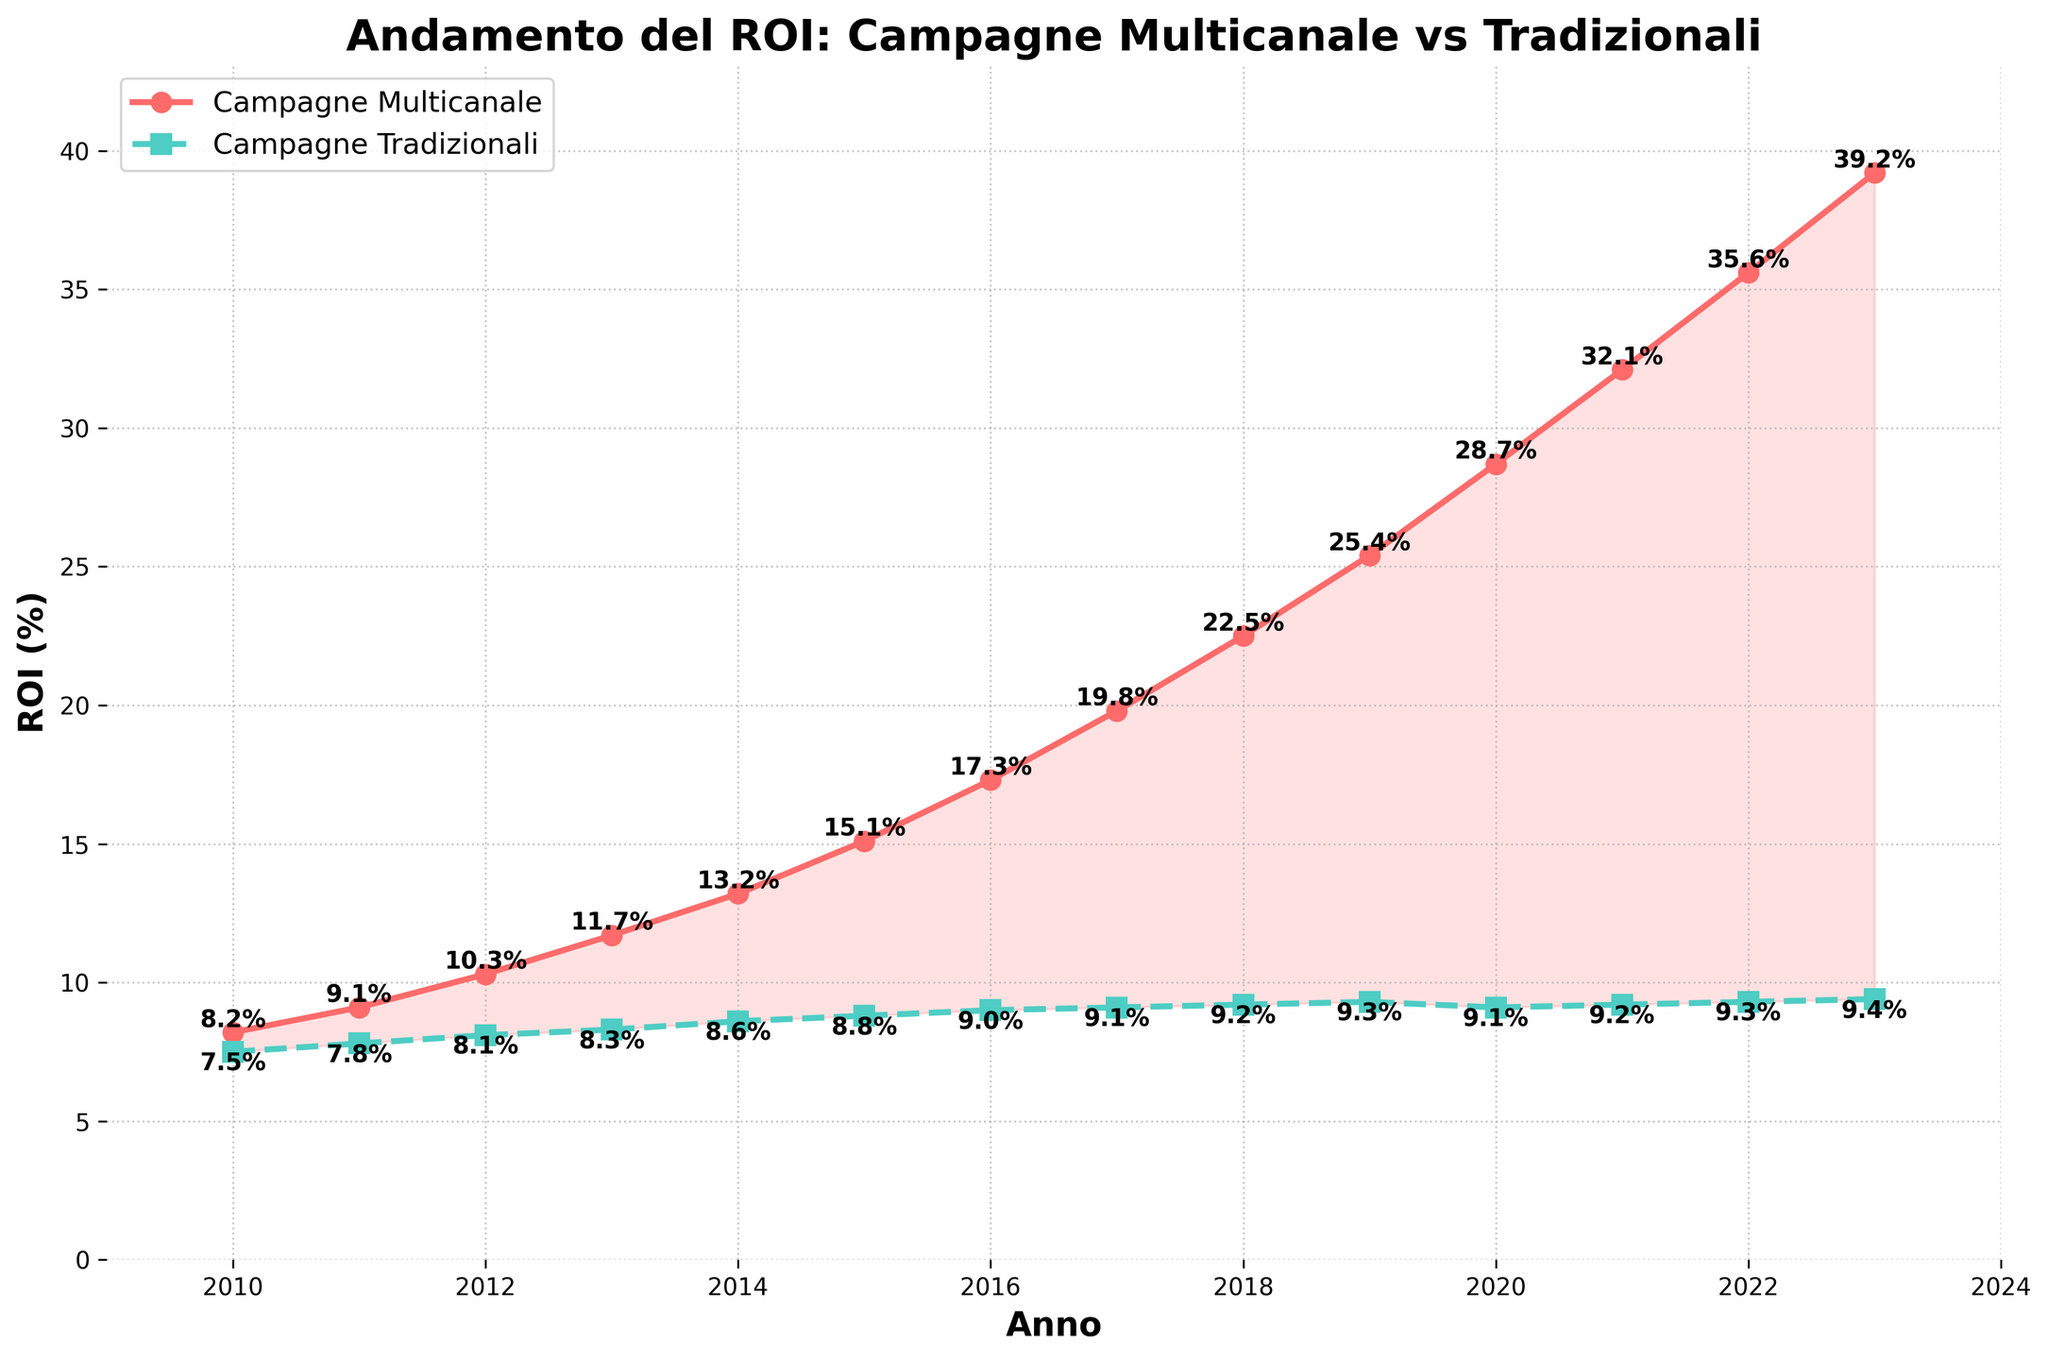Which type of campaign had a higher ROI in 2015? In 2015, the ROI for multichannel campaigns was 15.1%, and for traditional campaigns it was 8.8%. Since 15.1% is greater, the multichannel campaigns had a higher ROI.
Answer: Multichannel campaigns What was the percentage increase in ROI for multichannel campaigns from 2010 to 2023? The multichannel campaign ROI in 2010 was 8.2%, and in 2023 it was 39.2%. The percentage increase is calculated as (39.2% - 8.2%) / 8.2% * 100%. This results in a percentage increase of about 378%.
Answer: 378% Which year had the smallest difference in ROI between multichannel and traditional campaigns? By visually comparing the differences shown on the plot, 2013 had the smallest difference, as the values were 11.7% for multichannel and 8.3% for traditional, resulting in a difference of 3.4%.
Answer: 2013 How many years did the ROI for multichannel campaigns remain above 30%? By looking at the x-axis and seeing where the curve for multichannel campaigns crosses 30%, we identify that it remains above 30% from 2021 to 2023.
Answer: 3 years In which year did traditional campaigns experience the highest ROI? Observing the plot, the traditional campaigns had the highest ROI in 2023 with 9.4%.
Answer: 2023 What is the average ROI for traditional campaigns over the period 2010 to 2023? The average is calculated by summing the ROI values for traditional campaigns and dividing by the number of years (14). The sum is 7.5 + 7.8 + 8.1 + 8.3 + 8.6 + 8.8 + 9.0 + 9.1 + 9.2 + 9.3 + 9.1 + 9.2 + 9.3 + 9.4 = 122.7, and the average is 122.7 / 14.
Answer: 8.8% Did the ROI of multichannel campaigns ever decrease? By examining the trend line for multichannel campaigns, there is no downward slope; the ROI increases consistently every year.
Answer: No What was the ROI gap between multichannel and traditional campaigns in 2020? In 2020, the multichannel campaign ROI was 28.7%, and for traditional campaigns, it was 9.1%. The gap is 28.7% - 9.1% = 19.6%.
Answer: 19.6% During which year did the ROI for multichannel campaigns first exceed 20%? By tracing the plot, multichannel campaigns first exceeded 20% between 2017 and 2018, specifically starting from 2018.
Answer: 2018 What visual element indicates the area where multichannel campaigns had a higher ROI than traditional campaigns? The red shaded area between the two lines on the plot indicates where multichannel campaigns had a higher ROI than traditional campaigns.
Answer: Red shaded area 